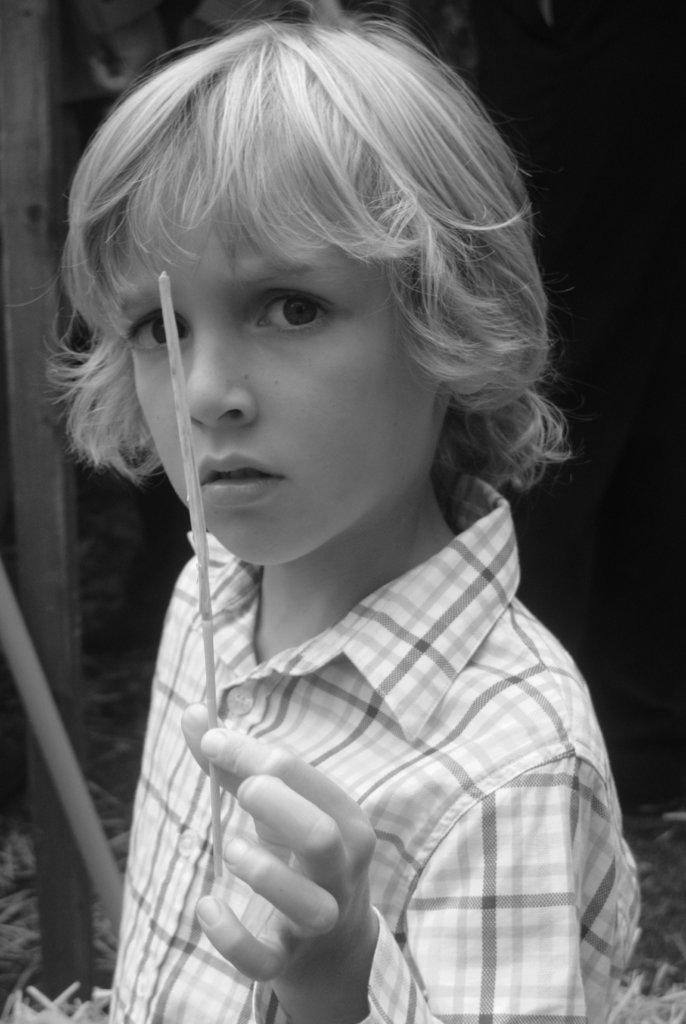What is the main subject of the image? The main subject of the image is a kid. What is the kid holding in his hand? The kid is holding a dry stick in his hand. What color scheme is used in the image? The image is in black and white color. What type of heart-shaped object can be seen in the image? There is no heart-shaped object present in the image. How many hands are visible in the image? The image only shows one kid, so only one hand is visible. 